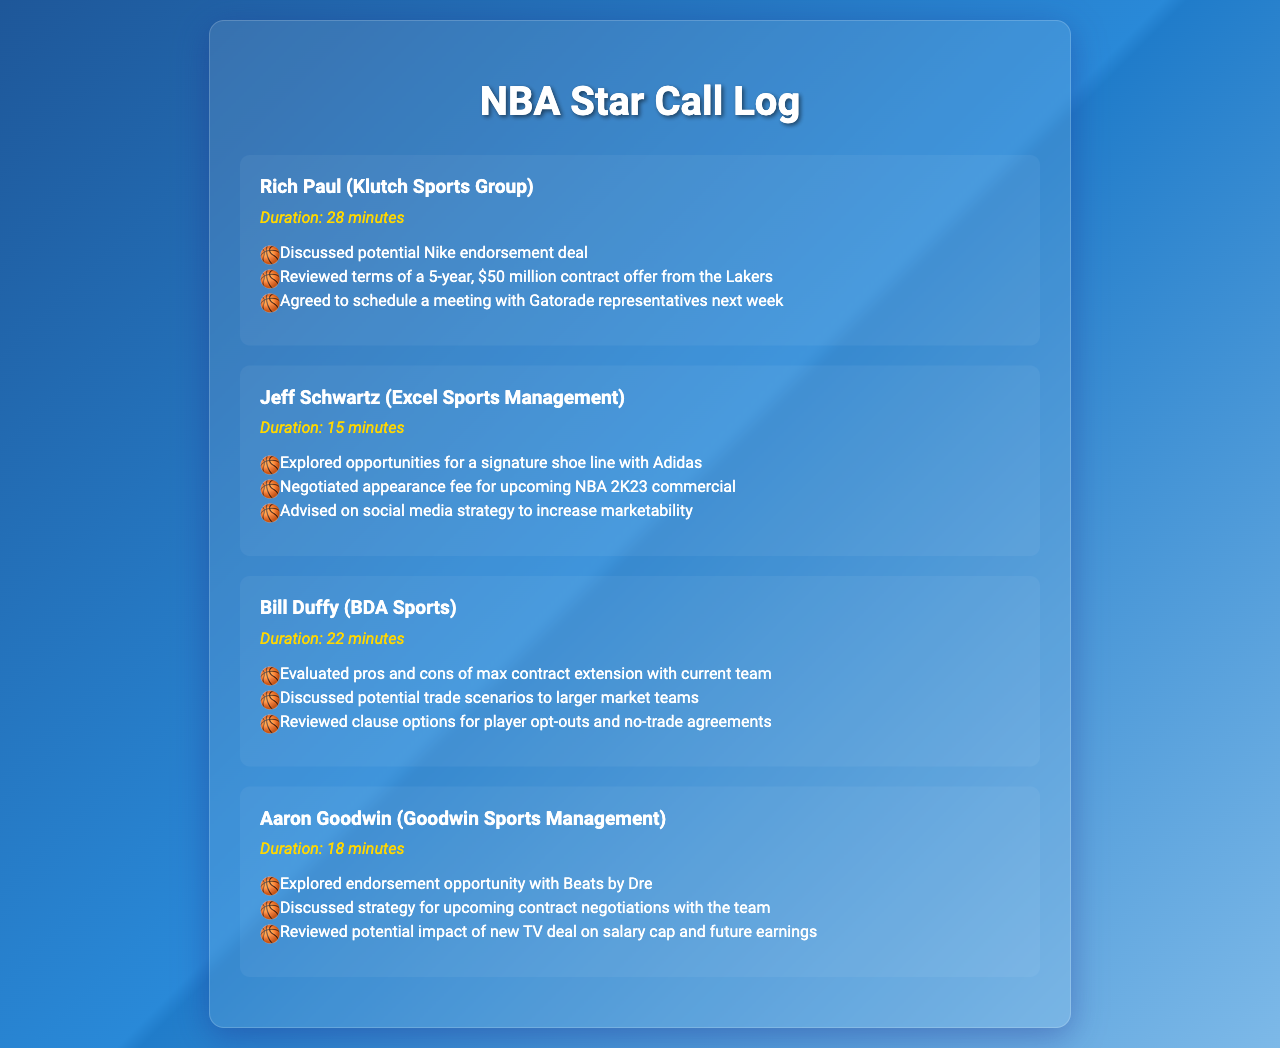What was the duration of the call with Rich Paul? The duration of the call with Rich Paul is stated in the document as 28 minutes.
Answer: 28 minutes What endorsement deal was discussed with Rich Paul? The document mentions a potential Nike endorsement deal during the conversation with Rich Paul.
Answer: Nike How long was the call with Jeff Schwartz? The document states that the call with Jeff Schwartz lasted 15 minutes.
Answer: 15 minutes Which company was mentioned for a signature shoe line? During the call with Jeff Schwartz, Adidas was identified as the company for a signature shoe line.
Answer: Adidas What was the main topic discussed with Bill Duffy? The document indicates that the pros and cons of a max contract extension with the current team were evaluated with Bill Duffy.
Answer: max contract extension Which strategy was discussed with Aaron Goodwin? The document mentions discussing a strategy for upcoming contract negotiations with the team with Aaron Goodwin.
Answer: contract negotiations Who is the agent discussing a potential trade scenario? Bill Duffy is the agent who discussed potential trade scenarios to larger market teams.
Answer: Bill Duffy How many minutes was the conversation with Aaron Goodwin? The document notes that the conversation with Aaron Goodwin lasted 18 minutes.
Answer: 18 minutes What item was negotiated for an upcoming commercial with Jeff Schwartz? The negotiation with Jeff Schwartz was for an appearance fee for the NBA 2K23 commercial.
Answer: appearance fee 